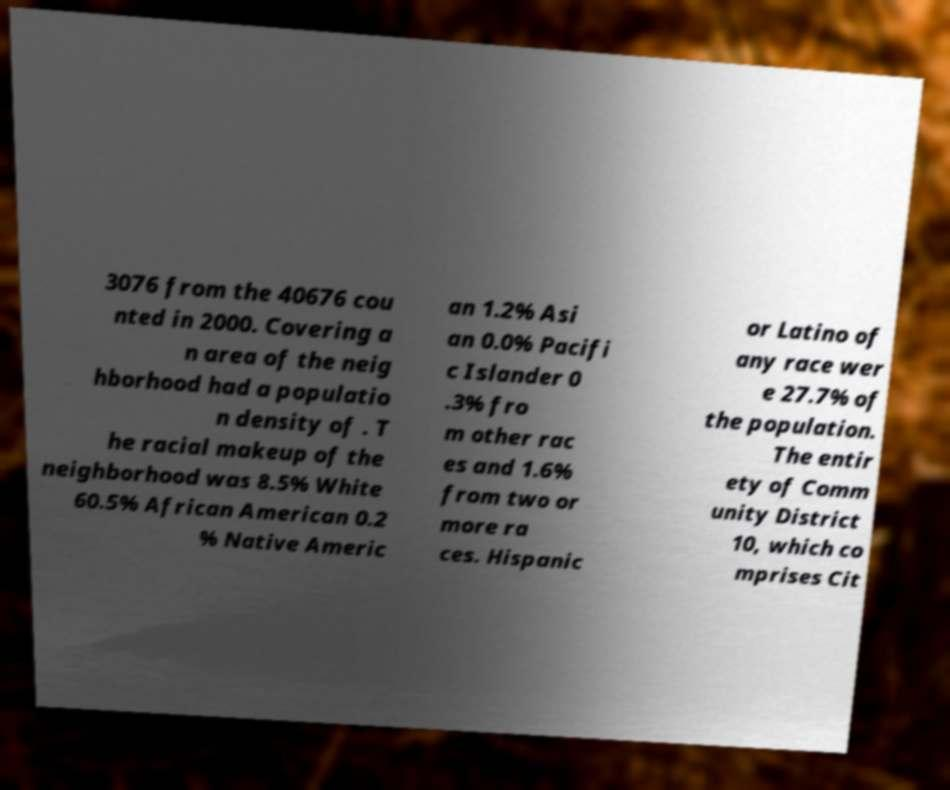What messages or text are displayed in this image? I need them in a readable, typed format. 3076 from the 40676 cou nted in 2000. Covering a n area of the neig hborhood had a populatio n density of . T he racial makeup of the neighborhood was 8.5% White 60.5% African American 0.2 % Native Americ an 1.2% Asi an 0.0% Pacifi c Islander 0 .3% fro m other rac es and 1.6% from two or more ra ces. Hispanic or Latino of any race wer e 27.7% of the population. The entir ety of Comm unity District 10, which co mprises Cit 